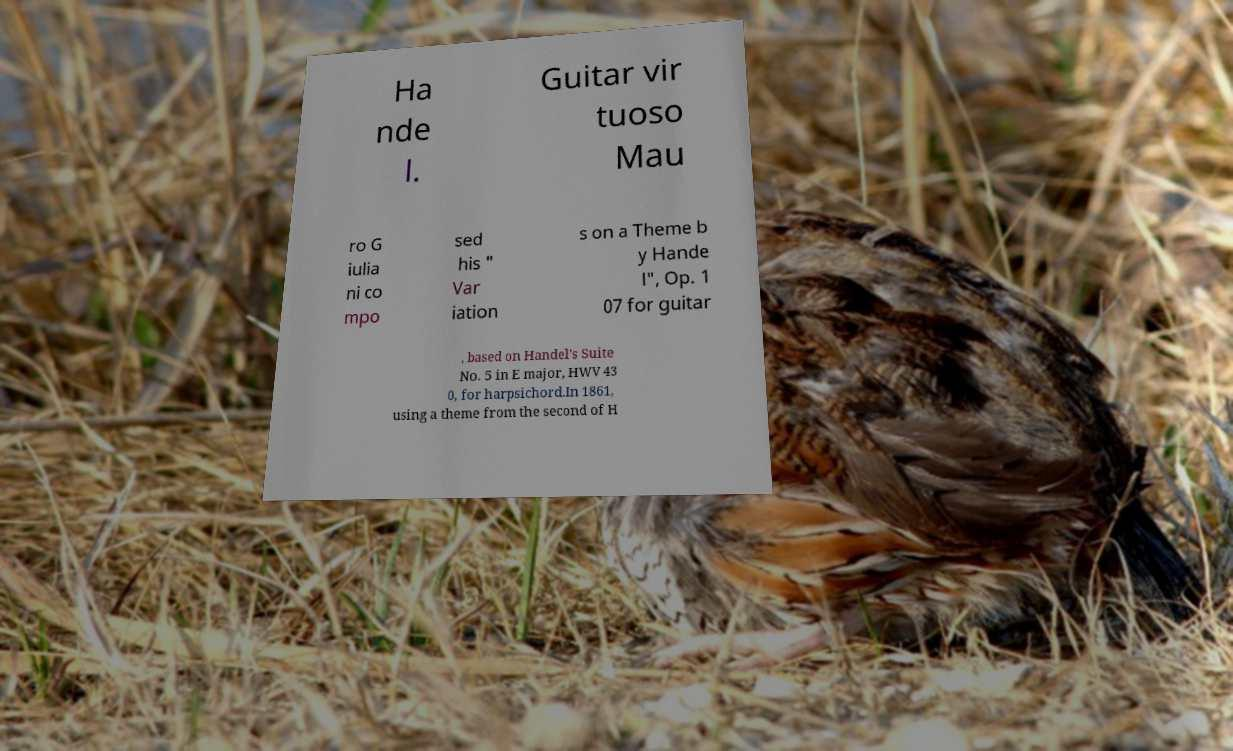Could you extract and type out the text from this image? Ha nde l. Guitar vir tuoso Mau ro G iulia ni co mpo sed his " Var iation s on a Theme b y Hande l", Op. 1 07 for guitar , based on Handel's Suite No. 5 in E major, HWV 43 0, for harpsichord.In 1861, using a theme from the second of H 